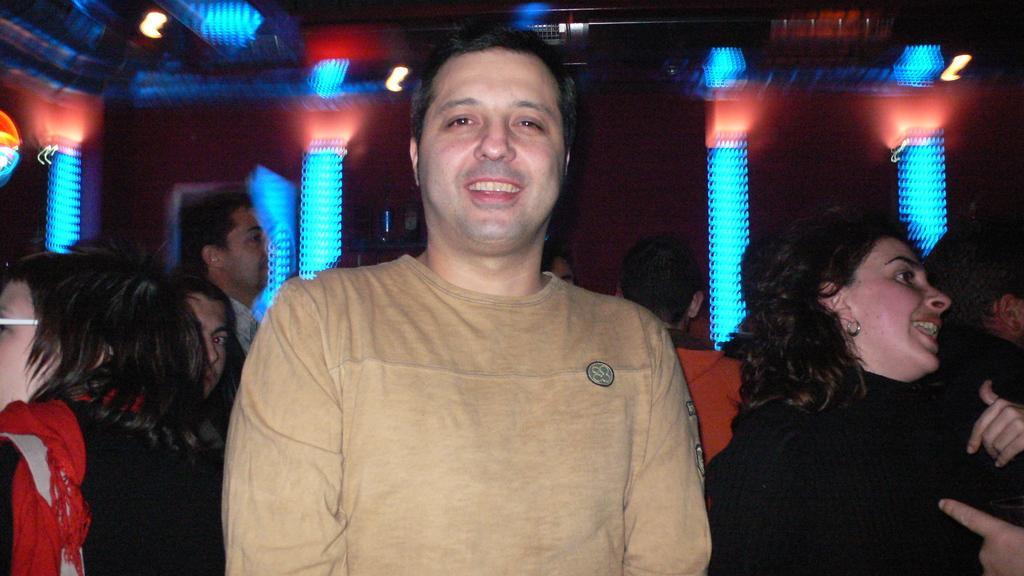In one or two sentences, can you explain what this image depicts? Here I can see a man wearing a t-shirt and smiling by looking at the picture. At the back of him there are many people. It seems like they are dancing. In the background there are few lights in the dark. 